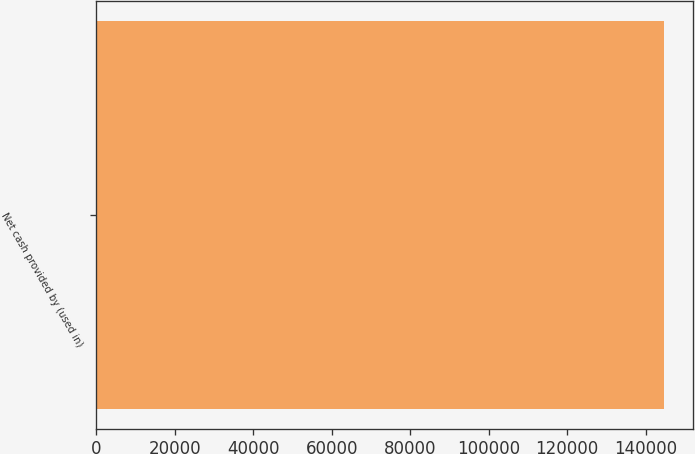Convert chart. <chart><loc_0><loc_0><loc_500><loc_500><bar_chart><fcel>Net cash provided by (used in)<nl><fcel>144731<nl></chart> 